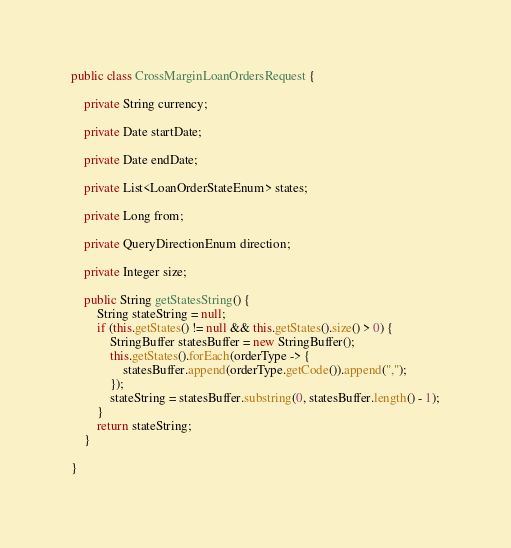<code> <loc_0><loc_0><loc_500><loc_500><_Java_>public class CrossMarginLoanOrdersRequest {

    private String currency;

    private Date startDate;

    private Date endDate;

    private List<LoanOrderStateEnum> states;

    private Long from;

    private QueryDirectionEnum direction;

    private Integer size;

    public String getStatesString() {
        String stateString = null;
        if (this.getStates() != null && this.getStates().size() > 0) {
            StringBuffer statesBuffer = new StringBuffer();
            this.getStates().forEach(orderType -> {
                statesBuffer.append(orderType.getCode()).append(",");
            });
            stateString = statesBuffer.substring(0, statesBuffer.length() - 1);
        }
        return stateString;
    }

}
</code> 